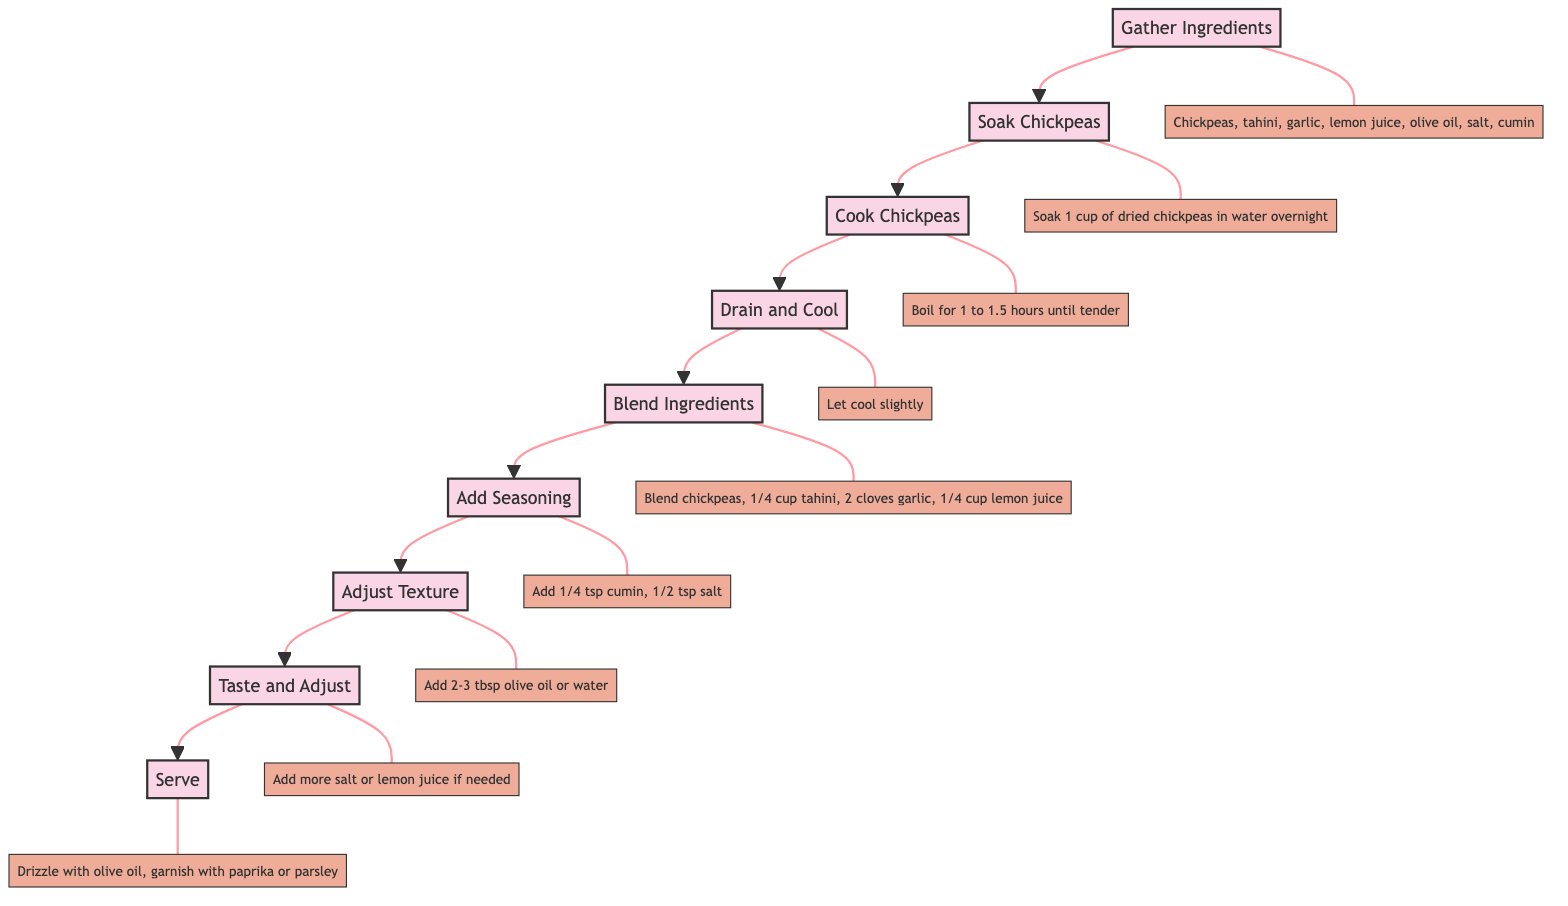What is the first step in making traditional hummus? The first step indicated in the diagram is "Gather Ingredients," which initiates the process of making traditional hummus.
Answer: Gather Ingredients How many main steps are there in the process? By counting the nodes labeled in the flowchart, there are a total of nine distinct steps from gathering ingredients to serving the hummus.
Answer: 9 What is added after blending the initial ingredients? According to the flowchart, after blending, the next action is to "Add Seasoning," indicating the introduction of spices for taste.
Answer: Add Seasoning What should be done after cooking the chickpeas? The diagram specifies that after cooking the chickpeas, the next step is to "Drain and Cool," which allows the cooked chickpeas to be prepared for blending.
Answer: Drain and Cool What is the last action to take in the process? The flowchart clearly states that the final action is to "Serve," indicating the completion of the hummus-making process and its presentation.
Answer: Serve Which step involves adjusting for taste? The relevant step covering taste adjustments is "Taste and Adjust," where you can enhance the flavor by adding more salt or lemon juice.
Answer: Taste and Adjust What should you gradually add to adjust the texture? The diagram notes that you should gradually add "2 to 3 tablespoons of olive oil (or water)" while blending to reach the desired consistency of the hummus.
Answer: Olive oil (or water) What is blended together in the "Blend Ingredients" step? In the "Blend Ingredients" step, the ingredients indicated to be blended are chickpeas, tahini, garlic, and lemon juice till smooth.
Answer: Chickpeas, tahini, garlic, lemon juice 